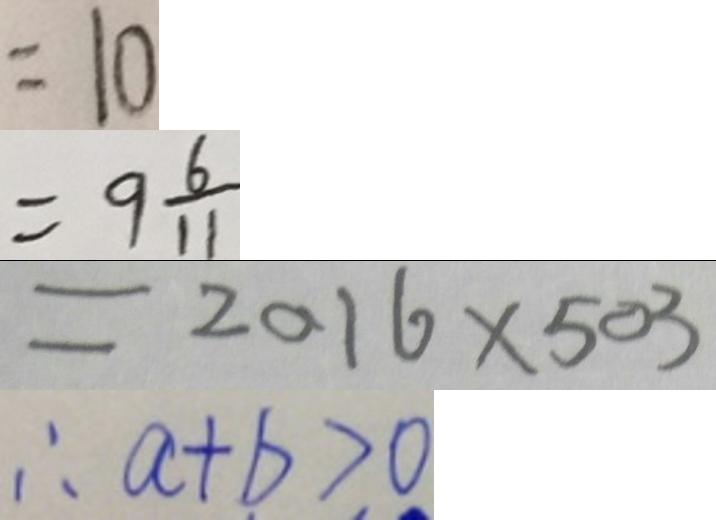Convert formula to latex. <formula><loc_0><loc_0><loc_500><loc_500>= 1 0 
 = 9 \frac { 6 } { 1 1 } 
 = 2 0 1 6 \times 5 0 3 
 \therefore a + b > 0</formula> 